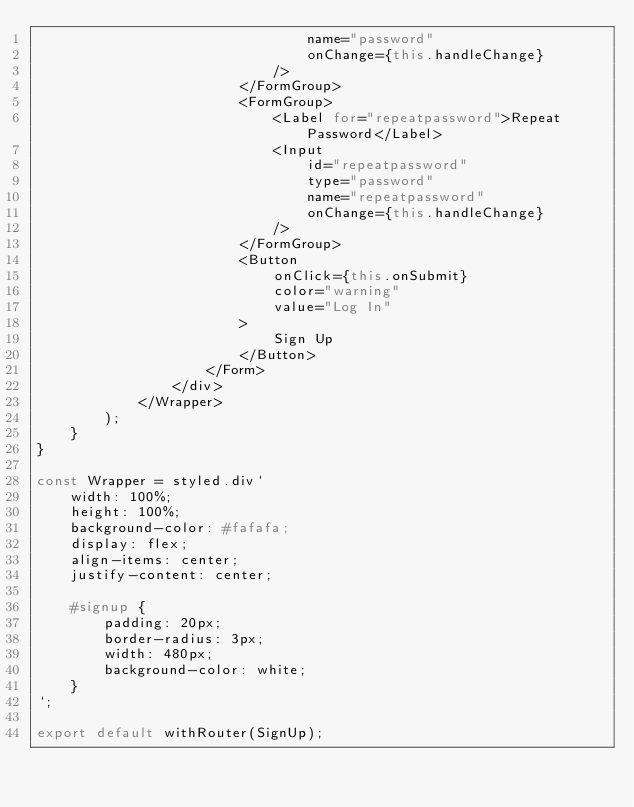<code> <loc_0><loc_0><loc_500><loc_500><_JavaScript_>                                name="password"
                                onChange={this.handleChange}
                            />
                        </FormGroup>
                        <FormGroup>
                            <Label for="repeatpassword">Repeat Password</Label>
                            <Input
                                id="repeatpassword"
                                type="password"
                                name="repeatpassword"
                                onChange={this.handleChange}
                            />
                        </FormGroup>
                        <Button
                            onClick={this.onSubmit}
                            color="warning"
                            value="Log In"
                        >
                            Sign Up
                        </Button>
                    </Form>
                </div>
            </Wrapper>
        );
    }
}

const Wrapper = styled.div`
    width: 100%;
    height: 100%;
    background-color: #fafafa;
    display: flex;
    align-items: center;
    justify-content: center;

    #signup {
        padding: 20px;
        border-radius: 3px;
        width: 480px;
        background-color: white;
    }
`;

export default withRouter(SignUp);
</code> 